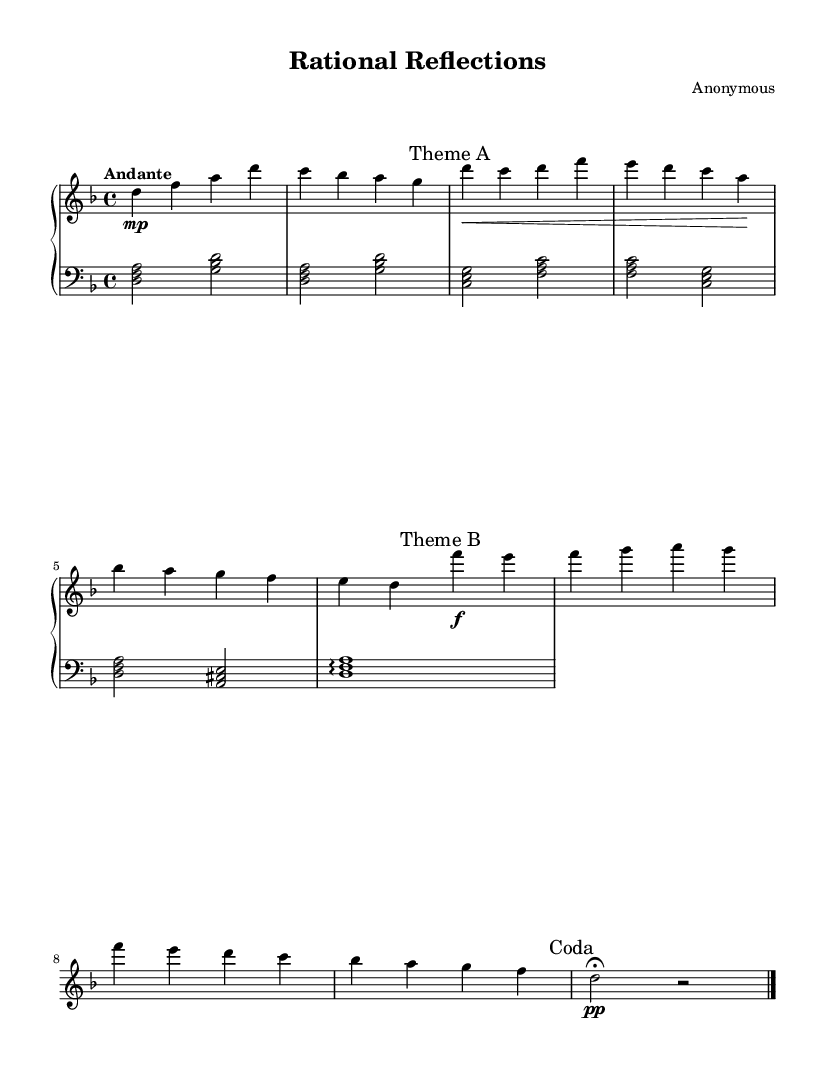What is the key signature of this music? The piece is in D minor, indicated by the presence of one flat (B flat) in the key signature. This involves looking at the key signature marked on the staff at the beginning of the piece.
Answer: D minor What is the time signature of the piece? The time signature is 4/4, which is indicated at the beginning of the score, telling us that there are four beats in each measure and a quarter note receives one beat.
Answer: 4/4 What is the tempo marking for the piece? The tempo marking is "Andante," found written at the beginning. This term typically indicates a moderate pace, which affects how the piece is performed.
Answer: Andante How many themes are in this composition? There are two distinct themes labeled as "Theme A" and "Theme B," indicated in the score with respective marking lines which signal a change in the music.
Answer: Two What is the dynamic marking for Theme A? The dynamic marking for Theme A is mezzo piano, which is indicated by the marking "mp" placed at the start of that section. This means it should be played moderately soft.
Answer: mezzo piano In which section does the piece conclude? The piece concludes with a "Coda," marked at the end of the composition. This section typically serves as a closing passage, often following the themes.
Answer: Coda What kind of chord is played in the left hand during the introduction? The left hand plays a D minor chord during the introduction, identified by the notes being played together (D, F, A), which align with the root position of the D minor triad.
Answer: D minor chord 